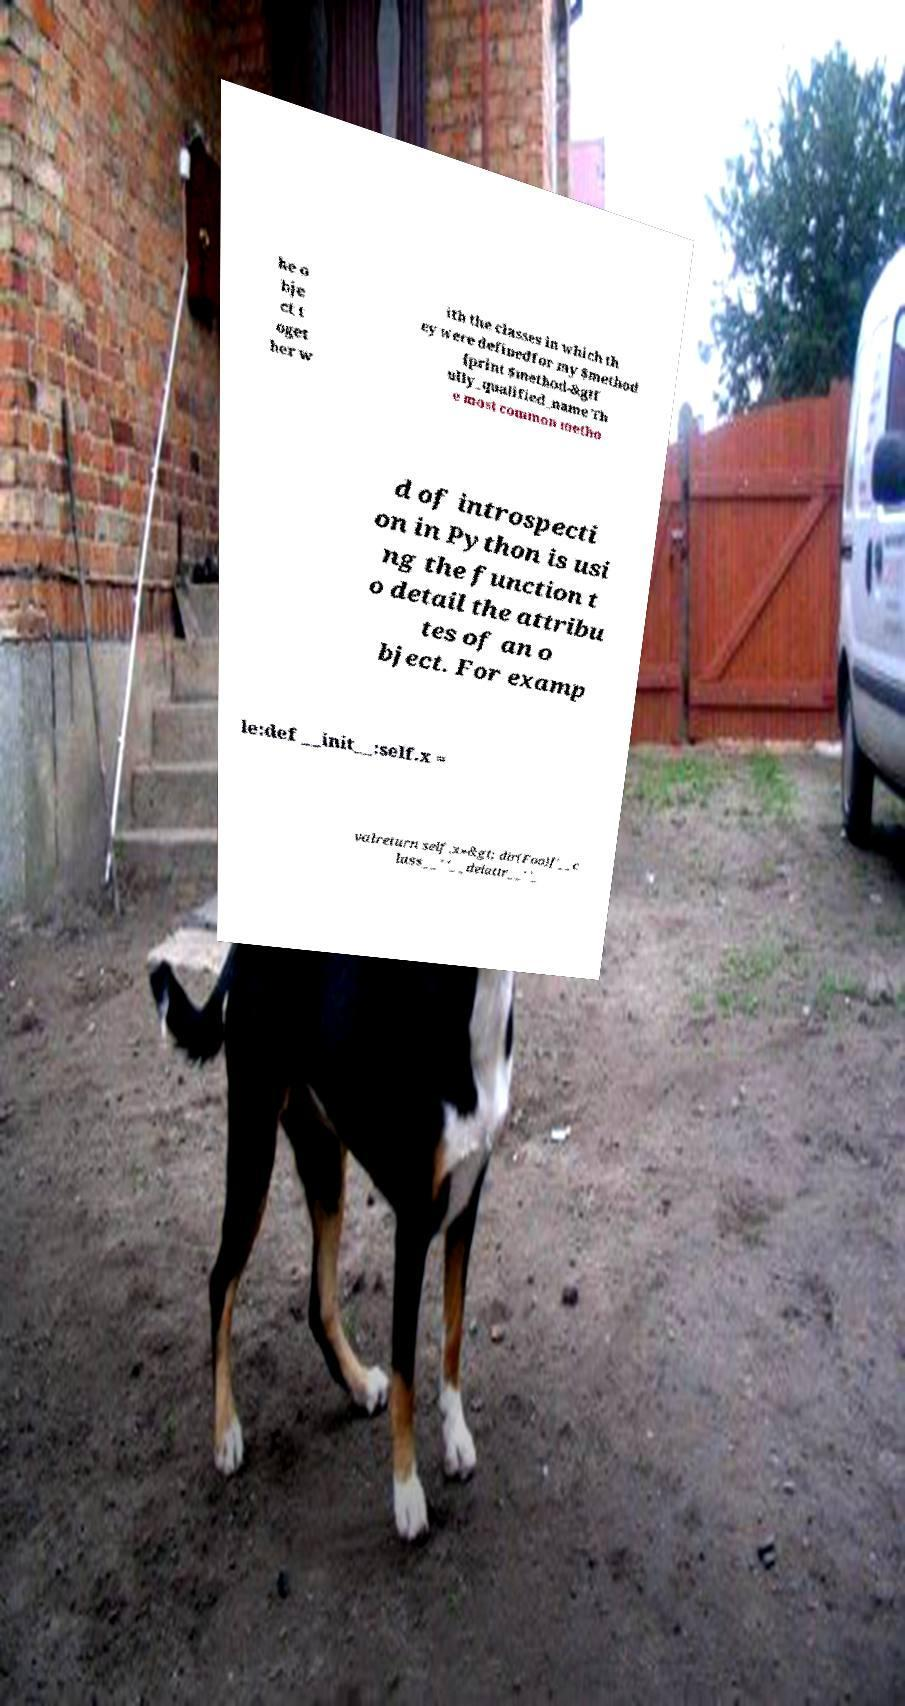What messages or text are displayed in this image? I need them in a readable, typed format. he o bje ct t oget her w ith the classes in which th ey were definedfor my $method {print $method-&gtf ully_qualified_name Th e most common metho d of introspecti on in Python is usi ng the function t o detail the attribu tes of an o bject. For examp le:def __init__:self.x = valreturn self.x»&gt; dir(Foo)['__c lass__' '__delattr__' '_ 